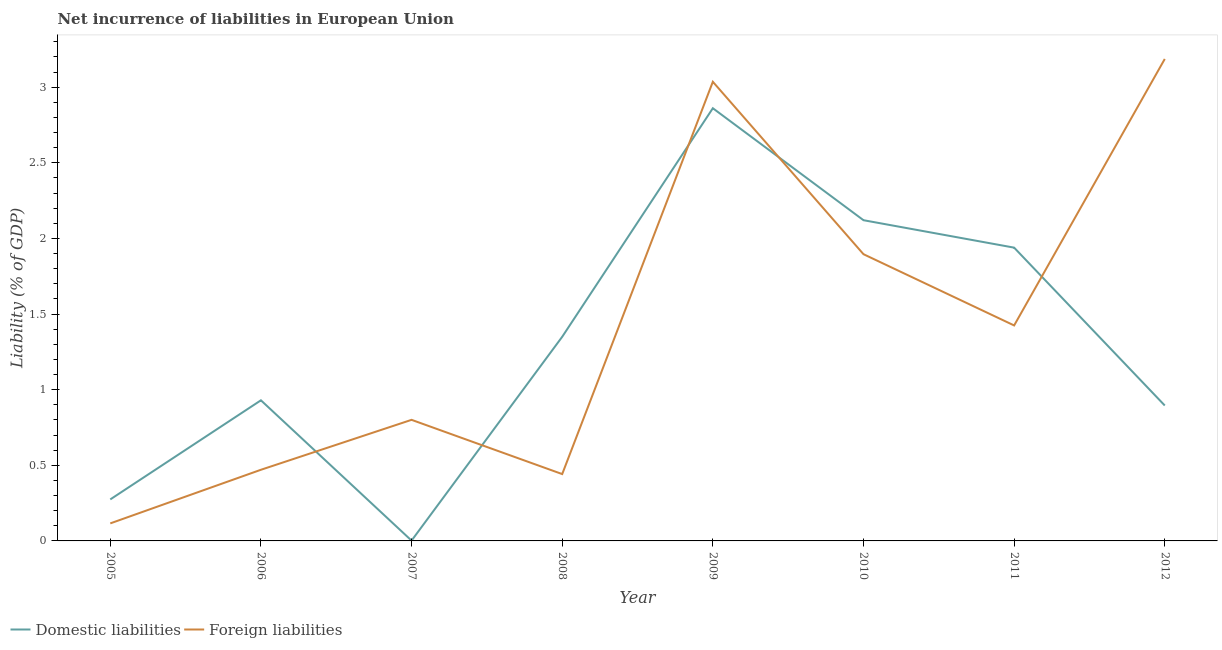What is the incurrence of domestic liabilities in 2010?
Your answer should be very brief. 2.12. Across all years, what is the maximum incurrence of domestic liabilities?
Your answer should be compact. 2.86. Across all years, what is the minimum incurrence of domestic liabilities?
Provide a succinct answer. 0. What is the total incurrence of domestic liabilities in the graph?
Offer a terse response. 10.37. What is the difference between the incurrence of domestic liabilities in 2008 and that in 2012?
Your answer should be compact. 0.45. What is the difference between the incurrence of domestic liabilities in 2006 and the incurrence of foreign liabilities in 2010?
Keep it short and to the point. -0.97. What is the average incurrence of domestic liabilities per year?
Ensure brevity in your answer.  1.3. In the year 2008, what is the difference between the incurrence of foreign liabilities and incurrence of domestic liabilities?
Your response must be concise. -0.91. What is the ratio of the incurrence of domestic liabilities in 2008 to that in 2009?
Offer a very short reply. 0.47. Is the difference between the incurrence of domestic liabilities in 2005 and 2012 greater than the difference between the incurrence of foreign liabilities in 2005 and 2012?
Your response must be concise. Yes. What is the difference between the highest and the second highest incurrence of domestic liabilities?
Offer a terse response. 0.74. What is the difference between the highest and the lowest incurrence of domestic liabilities?
Provide a short and direct response. 2.86. Is the incurrence of domestic liabilities strictly greater than the incurrence of foreign liabilities over the years?
Your response must be concise. No. Are the values on the major ticks of Y-axis written in scientific E-notation?
Offer a very short reply. No. Does the graph contain any zero values?
Your response must be concise. No. Does the graph contain grids?
Make the answer very short. No. Where does the legend appear in the graph?
Your response must be concise. Bottom left. How are the legend labels stacked?
Provide a succinct answer. Horizontal. What is the title of the graph?
Make the answer very short. Net incurrence of liabilities in European Union. Does "Register a business" appear as one of the legend labels in the graph?
Make the answer very short. No. What is the label or title of the Y-axis?
Your answer should be very brief. Liability (% of GDP). What is the Liability (% of GDP) in Domestic liabilities in 2005?
Give a very brief answer. 0.27. What is the Liability (% of GDP) of Foreign liabilities in 2005?
Make the answer very short. 0.12. What is the Liability (% of GDP) in Domestic liabilities in 2006?
Provide a succinct answer. 0.93. What is the Liability (% of GDP) in Foreign liabilities in 2006?
Provide a succinct answer. 0.47. What is the Liability (% of GDP) in Domestic liabilities in 2007?
Keep it short and to the point. 0. What is the Liability (% of GDP) of Foreign liabilities in 2007?
Give a very brief answer. 0.8. What is the Liability (% of GDP) of Domestic liabilities in 2008?
Provide a short and direct response. 1.35. What is the Liability (% of GDP) of Foreign liabilities in 2008?
Provide a succinct answer. 0.44. What is the Liability (% of GDP) of Domestic liabilities in 2009?
Provide a short and direct response. 2.86. What is the Liability (% of GDP) of Foreign liabilities in 2009?
Provide a succinct answer. 3.04. What is the Liability (% of GDP) of Domestic liabilities in 2010?
Offer a very short reply. 2.12. What is the Liability (% of GDP) in Foreign liabilities in 2010?
Ensure brevity in your answer.  1.9. What is the Liability (% of GDP) in Domestic liabilities in 2011?
Ensure brevity in your answer.  1.94. What is the Liability (% of GDP) of Foreign liabilities in 2011?
Provide a succinct answer. 1.42. What is the Liability (% of GDP) in Domestic liabilities in 2012?
Keep it short and to the point. 0.9. What is the Liability (% of GDP) of Foreign liabilities in 2012?
Your answer should be very brief. 3.19. Across all years, what is the maximum Liability (% of GDP) of Domestic liabilities?
Ensure brevity in your answer.  2.86. Across all years, what is the maximum Liability (% of GDP) in Foreign liabilities?
Ensure brevity in your answer.  3.19. Across all years, what is the minimum Liability (% of GDP) in Domestic liabilities?
Your answer should be compact. 0. Across all years, what is the minimum Liability (% of GDP) of Foreign liabilities?
Keep it short and to the point. 0.12. What is the total Liability (% of GDP) of Domestic liabilities in the graph?
Offer a very short reply. 10.37. What is the total Liability (% of GDP) in Foreign liabilities in the graph?
Provide a short and direct response. 11.37. What is the difference between the Liability (% of GDP) of Domestic liabilities in 2005 and that in 2006?
Provide a short and direct response. -0.66. What is the difference between the Liability (% of GDP) of Foreign liabilities in 2005 and that in 2006?
Make the answer very short. -0.35. What is the difference between the Liability (% of GDP) in Domestic liabilities in 2005 and that in 2007?
Keep it short and to the point. 0.27. What is the difference between the Liability (% of GDP) of Foreign liabilities in 2005 and that in 2007?
Give a very brief answer. -0.68. What is the difference between the Liability (% of GDP) of Domestic liabilities in 2005 and that in 2008?
Provide a short and direct response. -1.07. What is the difference between the Liability (% of GDP) in Foreign liabilities in 2005 and that in 2008?
Provide a short and direct response. -0.33. What is the difference between the Liability (% of GDP) of Domestic liabilities in 2005 and that in 2009?
Your response must be concise. -2.59. What is the difference between the Liability (% of GDP) in Foreign liabilities in 2005 and that in 2009?
Provide a succinct answer. -2.92. What is the difference between the Liability (% of GDP) in Domestic liabilities in 2005 and that in 2010?
Your answer should be compact. -1.85. What is the difference between the Liability (% of GDP) in Foreign liabilities in 2005 and that in 2010?
Keep it short and to the point. -1.78. What is the difference between the Liability (% of GDP) in Domestic liabilities in 2005 and that in 2011?
Your response must be concise. -1.66. What is the difference between the Liability (% of GDP) of Foreign liabilities in 2005 and that in 2011?
Give a very brief answer. -1.31. What is the difference between the Liability (% of GDP) in Domestic liabilities in 2005 and that in 2012?
Your answer should be very brief. -0.62. What is the difference between the Liability (% of GDP) of Foreign liabilities in 2005 and that in 2012?
Your answer should be compact. -3.07. What is the difference between the Liability (% of GDP) in Domestic liabilities in 2006 and that in 2007?
Offer a very short reply. 0.93. What is the difference between the Liability (% of GDP) of Foreign liabilities in 2006 and that in 2007?
Your response must be concise. -0.33. What is the difference between the Liability (% of GDP) in Domestic liabilities in 2006 and that in 2008?
Offer a terse response. -0.42. What is the difference between the Liability (% of GDP) in Foreign liabilities in 2006 and that in 2008?
Ensure brevity in your answer.  0.03. What is the difference between the Liability (% of GDP) in Domestic liabilities in 2006 and that in 2009?
Make the answer very short. -1.93. What is the difference between the Liability (% of GDP) in Foreign liabilities in 2006 and that in 2009?
Keep it short and to the point. -2.57. What is the difference between the Liability (% of GDP) in Domestic liabilities in 2006 and that in 2010?
Offer a terse response. -1.19. What is the difference between the Liability (% of GDP) of Foreign liabilities in 2006 and that in 2010?
Give a very brief answer. -1.43. What is the difference between the Liability (% of GDP) in Domestic liabilities in 2006 and that in 2011?
Keep it short and to the point. -1.01. What is the difference between the Liability (% of GDP) of Foreign liabilities in 2006 and that in 2011?
Your answer should be very brief. -0.95. What is the difference between the Liability (% of GDP) of Domestic liabilities in 2006 and that in 2012?
Give a very brief answer. 0.03. What is the difference between the Liability (% of GDP) of Foreign liabilities in 2006 and that in 2012?
Offer a very short reply. -2.72. What is the difference between the Liability (% of GDP) in Domestic liabilities in 2007 and that in 2008?
Provide a succinct answer. -1.35. What is the difference between the Liability (% of GDP) of Foreign liabilities in 2007 and that in 2008?
Keep it short and to the point. 0.36. What is the difference between the Liability (% of GDP) in Domestic liabilities in 2007 and that in 2009?
Your response must be concise. -2.86. What is the difference between the Liability (% of GDP) in Foreign liabilities in 2007 and that in 2009?
Your response must be concise. -2.23. What is the difference between the Liability (% of GDP) in Domestic liabilities in 2007 and that in 2010?
Your response must be concise. -2.12. What is the difference between the Liability (% of GDP) in Foreign liabilities in 2007 and that in 2010?
Ensure brevity in your answer.  -1.09. What is the difference between the Liability (% of GDP) in Domestic liabilities in 2007 and that in 2011?
Ensure brevity in your answer.  -1.94. What is the difference between the Liability (% of GDP) in Foreign liabilities in 2007 and that in 2011?
Provide a succinct answer. -0.62. What is the difference between the Liability (% of GDP) in Domestic liabilities in 2007 and that in 2012?
Offer a very short reply. -0.89. What is the difference between the Liability (% of GDP) in Foreign liabilities in 2007 and that in 2012?
Make the answer very short. -2.39. What is the difference between the Liability (% of GDP) in Domestic liabilities in 2008 and that in 2009?
Your answer should be very brief. -1.51. What is the difference between the Liability (% of GDP) in Foreign liabilities in 2008 and that in 2009?
Make the answer very short. -2.59. What is the difference between the Liability (% of GDP) in Domestic liabilities in 2008 and that in 2010?
Make the answer very short. -0.77. What is the difference between the Liability (% of GDP) in Foreign liabilities in 2008 and that in 2010?
Offer a terse response. -1.45. What is the difference between the Liability (% of GDP) of Domestic liabilities in 2008 and that in 2011?
Offer a very short reply. -0.59. What is the difference between the Liability (% of GDP) of Foreign liabilities in 2008 and that in 2011?
Provide a succinct answer. -0.98. What is the difference between the Liability (% of GDP) of Domestic liabilities in 2008 and that in 2012?
Offer a terse response. 0.45. What is the difference between the Liability (% of GDP) of Foreign liabilities in 2008 and that in 2012?
Your answer should be compact. -2.74. What is the difference between the Liability (% of GDP) in Domestic liabilities in 2009 and that in 2010?
Make the answer very short. 0.74. What is the difference between the Liability (% of GDP) of Foreign liabilities in 2009 and that in 2010?
Provide a short and direct response. 1.14. What is the difference between the Liability (% of GDP) in Domestic liabilities in 2009 and that in 2011?
Keep it short and to the point. 0.92. What is the difference between the Liability (% of GDP) in Foreign liabilities in 2009 and that in 2011?
Provide a succinct answer. 1.61. What is the difference between the Liability (% of GDP) of Domestic liabilities in 2009 and that in 2012?
Offer a very short reply. 1.97. What is the difference between the Liability (% of GDP) of Foreign liabilities in 2009 and that in 2012?
Your response must be concise. -0.15. What is the difference between the Liability (% of GDP) of Domestic liabilities in 2010 and that in 2011?
Provide a short and direct response. 0.18. What is the difference between the Liability (% of GDP) of Foreign liabilities in 2010 and that in 2011?
Ensure brevity in your answer.  0.47. What is the difference between the Liability (% of GDP) of Domestic liabilities in 2010 and that in 2012?
Keep it short and to the point. 1.23. What is the difference between the Liability (% of GDP) of Foreign liabilities in 2010 and that in 2012?
Your answer should be compact. -1.29. What is the difference between the Liability (% of GDP) of Domestic liabilities in 2011 and that in 2012?
Your answer should be very brief. 1.04. What is the difference between the Liability (% of GDP) in Foreign liabilities in 2011 and that in 2012?
Make the answer very short. -1.76. What is the difference between the Liability (% of GDP) in Domestic liabilities in 2005 and the Liability (% of GDP) in Foreign liabilities in 2006?
Ensure brevity in your answer.  -0.2. What is the difference between the Liability (% of GDP) of Domestic liabilities in 2005 and the Liability (% of GDP) of Foreign liabilities in 2007?
Your answer should be compact. -0.53. What is the difference between the Liability (% of GDP) of Domestic liabilities in 2005 and the Liability (% of GDP) of Foreign liabilities in 2008?
Your answer should be compact. -0.17. What is the difference between the Liability (% of GDP) in Domestic liabilities in 2005 and the Liability (% of GDP) in Foreign liabilities in 2009?
Provide a short and direct response. -2.76. What is the difference between the Liability (% of GDP) in Domestic liabilities in 2005 and the Liability (% of GDP) in Foreign liabilities in 2010?
Ensure brevity in your answer.  -1.62. What is the difference between the Liability (% of GDP) of Domestic liabilities in 2005 and the Liability (% of GDP) of Foreign liabilities in 2011?
Offer a terse response. -1.15. What is the difference between the Liability (% of GDP) in Domestic liabilities in 2005 and the Liability (% of GDP) in Foreign liabilities in 2012?
Offer a very short reply. -2.91. What is the difference between the Liability (% of GDP) of Domestic liabilities in 2006 and the Liability (% of GDP) of Foreign liabilities in 2007?
Keep it short and to the point. 0.13. What is the difference between the Liability (% of GDP) in Domestic liabilities in 2006 and the Liability (% of GDP) in Foreign liabilities in 2008?
Offer a very short reply. 0.49. What is the difference between the Liability (% of GDP) of Domestic liabilities in 2006 and the Liability (% of GDP) of Foreign liabilities in 2009?
Offer a very short reply. -2.11. What is the difference between the Liability (% of GDP) of Domestic liabilities in 2006 and the Liability (% of GDP) of Foreign liabilities in 2010?
Offer a terse response. -0.97. What is the difference between the Liability (% of GDP) of Domestic liabilities in 2006 and the Liability (% of GDP) of Foreign liabilities in 2011?
Keep it short and to the point. -0.49. What is the difference between the Liability (% of GDP) in Domestic liabilities in 2006 and the Liability (% of GDP) in Foreign liabilities in 2012?
Your answer should be compact. -2.26. What is the difference between the Liability (% of GDP) of Domestic liabilities in 2007 and the Liability (% of GDP) of Foreign liabilities in 2008?
Give a very brief answer. -0.44. What is the difference between the Liability (% of GDP) in Domestic liabilities in 2007 and the Liability (% of GDP) in Foreign liabilities in 2009?
Keep it short and to the point. -3.03. What is the difference between the Liability (% of GDP) in Domestic liabilities in 2007 and the Liability (% of GDP) in Foreign liabilities in 2010?
Your answer should be compact. -1.89. What is the difference between the Liability (% of GDP) in Domestic liabilities in 2007 and the Liability (% of GDP) in Foreign liabilities in 2011?
Your answer should be very brief. -1.42. What is the difference between the Liability (% of GDP) of Domestic liabilities in 2007 and the Liability (% of GDP) of Foreign liabilities in 2012?
Offer a terse response. -3.18. What is the difference between the Liability (% of GDP) of Domestic liabilities in 2008 and the Liability (% of GDP) of Foreign liabilities in 2009?
Offer a very short reply. -1.69. What is the difference between the Liability (% of GDP) of Domestic liabilities in 2008 and the Liability (% of GDP) of Foreign liabilities in 2010?
Keep it short and to the point. -0.55. What is the difference between the Liability (% of GDP) of Domestic liabilities in 2008 and the Liability (% of GDP) of Foreign liabilities in 2011?
Your answer should be compact. -0.08. What is the difference between the Liability (% of GDP) of Domestic liabilities in 2008 and the Liability (% of GDP) of Foreign liabilities in 2012?
Ensure brevity in your answer.  -1.84. What is the difference between the Liability (% of GDP) of Domestic liabilities in 2009 and the Liability (% of GDP) of Foreign liabilities in 2010?
Provide a short and direct response. 0.96. What is the difference between the Liability (% of GDP) of Domestic liabilities in 2009 and the Liability (% of GDP) of Foreign liabilities in 2011?
Your response must be concise. 1.44. What is the difference between the Liability (% of GDP) in Domestic liabilities in 2009 and the Liability (% of GDP) in Foreign liabilities in 2012?
Offer a terse response. -0.33. What is the difference between the Liability (% of GDP) of Domestic liabilities in 2010 and the Liability (% of GDP) of Foreign liabilities in 2011?
Provide a succinct answer. 0.7. What is the difference between the Liability (% of GDP) in Domestic liabilities in 2010 and the Liability (% of GDP) in Foreign liabilities in 2012?
Your answer should be very brief. -1.07. What is the difference between the Liability (% of GDP) in Domestic liabilities in 2011 and the Liability (% of GDP) in Foreign liabilities in 2012?
Give a very brief answer. -1.25. What is the average Liability (% of GDP) of Domestic liabilities per year?
Provide a succinct answer. 1.3. What is the average Liability (% of GDP) of Foreign liabilities per year?
Keep it short and to the point. 1.42. In the year 2005, what is the difference between the Liability (% of GDP) of Domestic liabilities and Liability (% of GDP) of Foreign liabilities?
Ensure brevity in your answer.  0.16. In the year 2006, what is the difference between the Liability (% of GDP) in Domestic liabilities and Liability (% of GDP) in Foreign liabilities?
Offer a very short reply. 0.46. In the year 2007, what is the difference between the Liability (% of GDP) of Domestic liabilities and Liability (% of GDP) of Foreign liabilities?
Give a very brief answer. -0.8. In the year 2008, what is the difference between the Liability (% of GDP) in Domestic liabilities and Liability (% of GDP) in Foreign liabilities?
Make the answer very short. 0.91. In the year 2009, what is the difference between the Liability (% of GDP) of Domestic liabilities and Liability (% of GDP) of Foreign liabilities?
Make the answer very short. -0.17. In the year 2010, what is the difference between the Liability (% of GDP) in Domestic liabilities and Liability (% of GDP) in Foreign liabilities?
Your answer should be compact. 0.22. In the year 2011, what is the difference between the Liability (% of GDP) in Domestic liabilities and Liability (% of GDP) in Foreign liabilities?
Your answer should be compact. 0.51. In the year 2012, what is the difference between the Liability (% of GDP) in Domestic liabilities and Liability (% of GDP) in Foreign liabilities?
Provide a succinct answer. -2.29. What is the ratio of the Liability (% of GDP) in Domestic liabilities in 2005 to that in 2006?
Your answer should be compact. 0.3. What is the ratio of the Liability (% of GDP) of Foreign liabilities in 2005 to that in 2006?
Provide a short and direct response. 0.25. What is the ratio of the Liability (% of GDP) in Domestic liabilities in 2005 to that in 2007?
Provide a succinct answer. 126.76. What is the ratio of the Liability (% of GDP) in Foreign liabilities in 2005 to that in 2007?
Make the answer very short. 0.14. What is the ratio of the Liability (% of GDP) in Domestic liabilities in 2005 to that in 2008?
Your answer should be very brief. 0.2. What is the ratio of the Liability (% of GDP) in Foreign liabilities in 2005 to that in 2008?
Make the answer very short. 0.26. What is the ratio of the Liability (% of GDP) in Domestic liabilities in 2005 to that in 2009?
Make the answer very short. 0.1. What is the ratio of the Liability (% of GDP) in Foreign liabilities in 2005 to that in 2009?
Keep it short and to the point. 0.04. What is the ratio of the Liability (% of GDP) of Domestic liabilities in 2005 to that in 2010?
Ensure brevity in your answer.  0.13. What is the ratio of the Liability (% of GDP) in Foreign liabilities in 2005 to that in 2010?
Offer a terse response. 0.06. What is the ratio of the Liability (% of GDP) in Domestic liabilities in 2005 to that in 2011?
Offer a very short reply. 0.14. What is the ratio of the Liability (% of GDP) in Foreign liabilities in 2005 to that in 2011?
Give a very brief answer. 0.08. What is the ratio of the Liability (% of GDP) of Domestic liabilities in 2005 to that in 2012?
Provide a short and direct response. 0.31. What is the ratio of the Liability (% of GDP) of Foreign liabilities in 2005 to that in 2012?
Provide a succinct answer. 0.04. What is the ratio of the Liability (% of GDP) in Domestic liabilities in 2006 to that in 2007?
Give a very brief answer. 429.43. What is the ratio of the Liability (% of GDP) in Foreign liabilities in 2006 to that in 2007?
Provide a succinct answer. 0.59. What is the ratio of the Liability (% of GDP) in Domestic liabilities in 2006 to that in 2008?
Give a very brief answer. 0.69. What is the ratio of the Liability (% of GDP) of Foreign liabilities in 2006 to that in 2008?
Give a very brief answer. 1.06. What is the ratio of the Liability (% of GDP) in Domestic liabilities in 2006 to that in 2009?
Ensure brevity in your answer.  0.33. What is the ratio of the Liability (% of GDP) of Foreign liabilities in 2006 to that in 2009?
Your answer should be very brief. 0.15. What is the ratio of the Liability (% of GDP) in Domestic liabilities in 2006 to that in 2010?
Give a very brief answer. 0.44. What is the ratio of the Liability (% of GDP) in Foreign liabilities in 2006 to that in 2010?
Provide a short and direct response. 0.25. What is the ratio of the Liability (% of GDP) in Domestic liabilities in 2006 to that in 2011?
Offer a very short reply. 0.48. What is the ratio of the Liability (% of GDP) of Foreign liabilities in 2006 to that in 2011?
Keep it short and to the point. 0.33. What is the ratio of the Liability (% of GDP) in Domestic liabilities in 2006 to that in 2012?
Give a very brief answer. 1.04. What is the ratio of the Liability (% of GDP) in Foreign liabilities in 2006 to that in 2012?
Give a very brief answer. 0.15. What is the ratio of the Liability (% of GDP) in Domestic liabilities in 2007 to that in 2008?
Ensure brevity in your answer.  0. What is the ratio of the Liability (% of GDP) in Foreign liabilities in 2007 to that in 2008?
Keep it short and to the point. 1.81. What is the ratio of the Liability (% of GDP) of Domestic liabilities in 2007 to that in 2009?
Your response must be concise. 0. What is the ratio of the Liability (% of GDP) in Foreign liabilities in 2007 to that in 2009?
Offer a very short reply. 0.26. What is the ratio of the Liability (% of GDP) in Domestic liabilities in 2007 to that in 2010?
Offer a terse response. 0. What is the ratio of the Liability (% of GDP) of Foreign liabilities in 2007 to that in 2010?
Provide a succinct answer. 0.42. What is the ratio of the Liability (% of GDP) of Domestic liabilities in 2007 to that in 2011?
Keep it short and to the point. 0. What is the ratio of the Liability (% of GDP) of Foreign liabilities in 2007 to that in 2011?
Your answer should be very brief. 0.56. What is the ratio of the Liability (% of GDP) in Domestic liabilities in 2007 to that in 2012?
Ensure brevity in your answer.  0. What is the ratio of the Liability (% of GDP) of Foreign liabilities in 2007 to that in 2012?
Provide a short and direct response. 0.25. What is the ratio of the Liability (% of GDP) of Domestic liabilities in 2008 to that in 2009?
Provide a short and direct response. 0.47. What is the ratio of the Liability (% of GDP) in Foreign liabilities in 2008 to that in 2009?
Your answer should be very brief. 0.15. What is the ratio of the Liability (% of GDP) of Domestic liabilities in 2008 to that in 2010?
Give a very brief answer. 0.64. What is the ratio of the Liability (% of GDP) in Foreign liabilities in 2008 to that in 2010?
Your response must be concise. 0.23. What is the ratio of the Liability (% of GDP) in Domestic liabilities in 2008 to that in 2011?
Provide a succinct answer. 0.7. What is the ratio of the Liability (% of GDP) of Foreign liabilities in 2008 to that in 2011?
Provide a short and direct response. 0.31. What is the ratio of the Liability (% of GDP) in Domestic liabilities in 2008 to that in 2012?
Your answer should be compact. 1.51. What is the ratio of the Liability (% of GDP) of Foreign liabilities in 2008 to that in 2012?
Provide a succinct answer. 0.14. What is the ratio of the Liability (% of GDP) in Domestic liabilities in 2009 to that in 2010?
Offer a very short reply. 1.35. What is the ratio of the Liability (% of GDP) in Foreign liabilities in 2009 to that in 2010?
Give a very brief answer. 1.6. What is the ratio of the Liability (% of GDP) in Domestic liabilities in 2009 to that in 2011?
Offer a very short reply. 1.48. What is the ratio of the Liability (% of GDP) of Foreign liabilities in 2009 to that in 2011?
Provide a succinct answer. 2.13. What is the ratio of the Liability (% of GDP) of Domestic liabilities in 2009 to that in 2012?
Offer a terse response. 3.2. What is the ratio of the Liability (% of GDP) in Foreign liabilities in 2009 to that in 2012?
Your response must be concise. 0.95. What is the ratio of the Liability (% of GDP) of Domestic liabilities in 2010 to that in 2011?
Your response must be concise. 1.09. What is the ratio of the Liability (% of GDP) of Foreign liabilities in 2010 to that in 2011?
Offer a terse response. 1.33. What is the ratio of the Liability (% of GDP) in Domestic liabilities in 2010 to that in 2012?
Provide a short and direct response. 2.37. What is the ratio of the Liability (% of GDP) of Foreign liabilities in 2010 to that in 2012?
Your response must be concise. 0.59. What is the ratio of the Liability (% of GDP) in Domestic liabilities in 2011 to that in 2012?
Provide a short and direct response. 2.17. What is the ratio of the Liability (% of GDP) of Foreign liabilities in 2011 to that in 2012?
Ensure brevity in your answer.  0.45. What is the difference between the highest and the second highest Liability (% of GDP) of Domestic liabilities?
Make the answer very short. 0.74. What is the difference between the highest and the second highest Liability (% of GDP) of Foreign liabilities?
Give a very brief answer. 0.15. What is the difference between the highest and the lowest Liability (% of GDP) of Domestic liabilities?
Give a very brief answer. 2.86. What is the difference between the highest and the lowest Liability (% of GDP) of Foreign liabilities?
Keep it short and to the point. 3.07. 